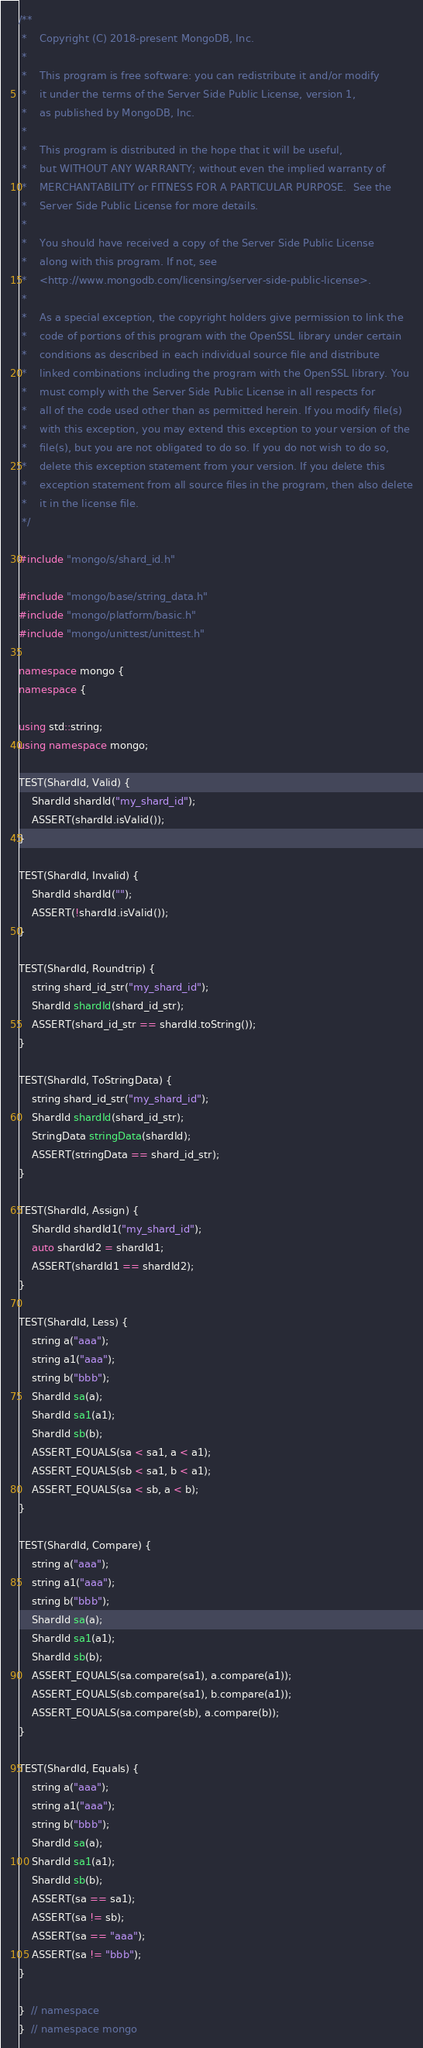<code> <loc_0><loc_0><loc_500><loc_500><_C++_>/**
 *    Copyright (C) 2018-present MongoDB, Inc.
 *
 *    This program is free software: you can redistribute it and/or modify
 *    it under the terms of the Server Side Public License, version 1,
 *    as published by MongoDB, Inc.
 *
 *    This program is distributed in the hope that it will be useful,
 *    but WITHOUT ANY WARRANTY; without even the implied warranty of
 *    MERCHANTABILITY or FITNESS FOR A PARTICULAR PURPOSE.  See the
 *    Server Side Public License for more details.
 *
 *    You should have received a copy of the Server Side Public License
 *    along with this program. If not, see
 *    <http://www.mongodb.com/licensing/server-side-public-license>.
 *
 *    As a special exception, the copyright holders give permission to link the
 *    code of portions of this program with the OpenSSL library under certain
 *    conditions as described in each individual source file and distribute
 *    linked combinations including the program with the OpenSSL library. You
 *    must comply with the Server Side Public License in all respects for
 *    all of the code used other than as permitted herein. If you modify file(s)
 *    with this exception, you may extend this exception to your version of the
 *    file(s), but you are not obligated to do so. If you do not wish to do so,
 *    delete this exception statement from your version. If you delete this
 *    exception statement from all source files in the program, then also delete
 *    it in the license file.
 */

#include "mongo/s/shard_id.h"

#include "mongo/base/string_data.h"
#include "mongo/platform/basic.h"
#include "mongo/unittest/unittest.h"

namespace mongo {
namespace {

using std::string;
using namespace mongo;

TEST(ShardId, Valid) {
    ShardId shardId("my_shard_id");
    ASSERT(shardId.isValid());
}

TEST(ShardId, Invalid) {
    ShardId shardId("");
    ASSERT(!shardId.isValid());
}

TEST(ShardId, Roundtrip) {
    string shard_id_str("my_shard_id");
    ShardId shardId(shard_id_str);
    ASSERT(shard_id_str == shardId.toString());
}

TEST(ShardId, ToStringData) {
    string shard_id_str("my_shard_id");
    ShardId shardId(shard_id_str);
    StringData stringData(shardId);
    ASSERT(stringData == shard_id_str);
}

TEST(ShardId, Assign) {
    ShardId shardId1("my_shard_id");
    auto shardId2 = shardId1;
    ASSERT(shardId1 == shardId2);
}

TEST(ShardId, Less) {
    string a("aaa");
    string a1("aaa");
    string b("bbb");
    ShardId sa(a);
    ShardId sa1(a1);
    ShardId sb(b);
    ASSERT_EQUALS(sa < sa1, a < a1);
    ASSERT_EQUALS(sb < sa1, b < a1);
    ASSERT_EQUALS(sa < sb, a < b);
}

TEST(ShardId, Compare) {
    string a("aaa");
    string a1("aaa");
    string b("bbb");
    ShardId sa(a);
    ShardId sa1(a1);
    ShardId sb(b);
    ASSERT_EQUALS(sa.compare(sa1), a.compare(a1));
    ASSERT_EQUALS(sb.compare(sa1), b.compare(a1));
    ASSERT_EQUALS(sa.compare(sb), a.compare(b));
}

TEST(ShardId, Equals) {
    string a("aaa");
    string a1("aaa");
    string b("bbb");
    ShardId sa(a);
    ShardId sa1(a1);
    ShardId sb(b);
    ASSERT(sa == sa1);
    ASSERT(sa != sb);
    ASSERT(sa == "aaa");
    ASSERT(sa != "bbb");
}

}  // namespace
}  // namespace mongo
</code> 